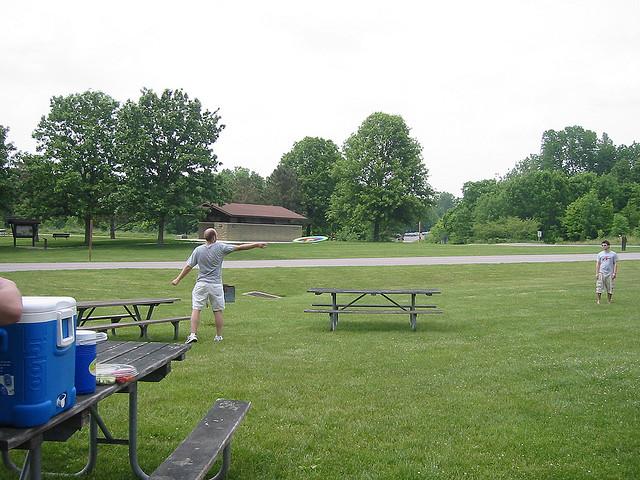What are they throwing?
Concise answer only. Frisbee. How long is the grass?
Give a very brief answer. Short. Does this sport require an open space area?
Concise answer only. Yes. 